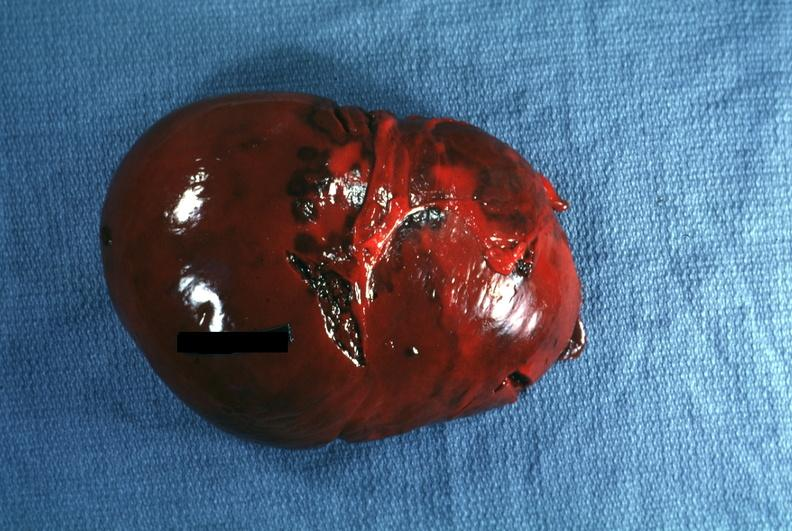where is this part in?
Answer the question using a single word or phrase. Spleen 